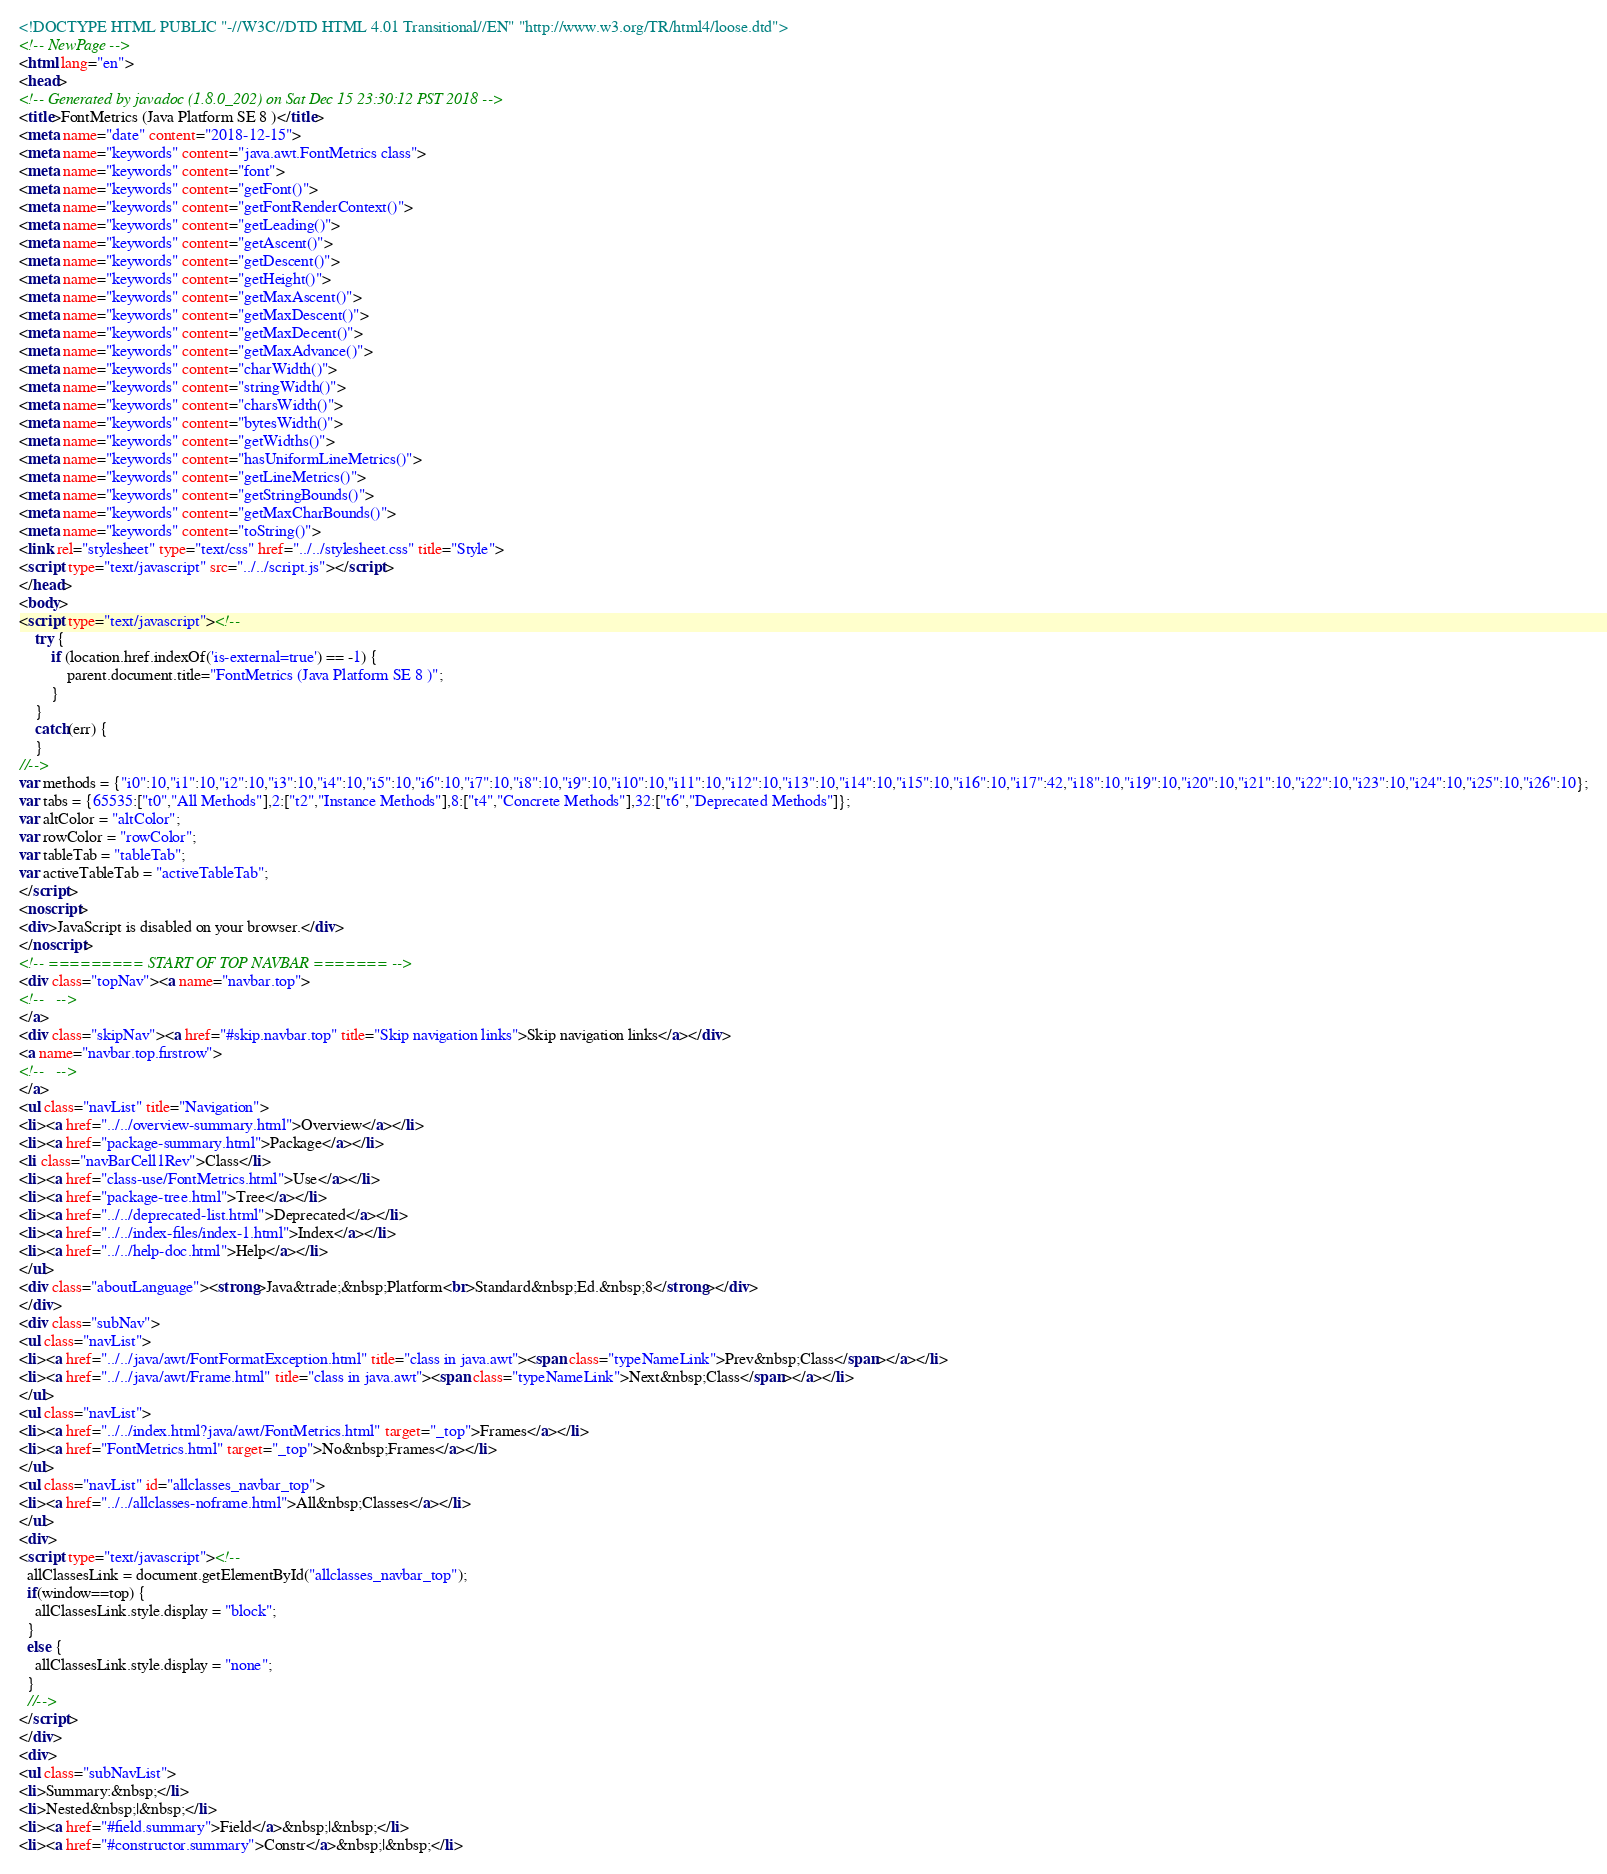<code> <loc_0><loc_0><loc_500><loc_500><_HTML_><!DOCTYPE HTML PUBLIC "-//W3C//DTD HTML 4.01 Transitional//EN" "http://www.w3.org/TR/html4/loose.dtd">
<!-- NewPage -->
<html lang="en">
<head>
<!-- Generated by javadoc (1.8.0_202) on Sat Dec 15 23:30:12 PST 2018 -->
<title>FontMetrics (Java Platform SE 8 )</title>
<meta name="date" content="2018-12-15">
<meta name="keywords" content="java.awt.FontMetrics class">
<meta name="keywords" content="font">
<meta name="keywords" content="getFont()">
<meta name="keywords" content="getFontRenderContext()">
<meta name="keywords" content="getLeading()">
<meta name="keywords" content="getAscent()">
<meta name="keywords" content="getDescent()">
<meta name="keywords" content="getHeight()">
<meta name="keywords" content="getMaxAscent()">
<meta name="keywords" content="getMaxDescent()">
<meta name="keywords" content="getMaxDecent()">
<meta name="keywords" content="getMaxAdvance()">
<meta name="keywords" content="charWidth()">
<meta name="keywords" content="stringWidth()">
<meta name="keywords" content="charsWidth()">
<meta name="keywords" content="bytesWidth()">
<meta name="keywords" content="getWidths()">
<meta name="keywords" content="hasUniformLineMetrics()">
<meta name="keywords" content="getLineMetrics()">
<meta name="keywords" content="getStringBounds()">
<meta name="keywords" content="getMaxCharBounds()">
<meta name="keywords" content="toString()">
<link rel="stylesheet" type="text/css" href="../../stylesheet.css" title="Style">
<script type="text/javascript" src="../../script.js"></script>
</head>
<body>
<script type="text/javascript"><!--
    try {
        if (location.href.indexOf('is-external=true') == -1) {
            parent.document.title="FontMetrics (Java Platform SE 8 )";
        }
    }
    catch(err) {
    }
//-->
var methods = {"i0":10,"i1":10,"i2":10,"i3":10,"i4":10,"i5":10,"i6":10,"i7":10,"i8":10,"i9":10,"i10":10,"i11":10,"i12":10,"i13":10,"i14":10,"i15":10,"i16":10,"i17":42,"i18":10,"i19":10,"i20":10,"i21":10,"i22":10,"i23":10,"i24":10,"i25":10,"i26":10};
var tabs = {65535:["t0","All Methods"],2:["t2","Instance Methods"],8:["t4","Concrete Methods"],32:["t6","Deprecated Methods"]};
var altColor = "altColor";
var rowColor = "rowColor";
var tableTab = "tableTab";
var activeTableTab = "activeTableTab";
</script>
<noscript>
<div>JavaScript is disabled on your browser.</div>
</noscript>
<!-- ========= START OF TOP NAVBAR ======= -->
<div class="topNav"><a name="navbar.top">
<!--   -->
</a>
<div class="skipNav"><a href="#skip.navbar.top" title="Skip navigation links">Skip navigation links</a></div>
<a name="navbar.top.firstrow">
<!--   -->
</a>
<ul class="navList" title="Navigation">
<li><a href="../../overview-summary.html">Overview</a></li>
<li><a href="package-summary.html">Package</a></li>
<li class="navBarCell1Rev">Class</li>
<li><a href="class-use/FontMetrics.html">Use</a></li>
<li><a href="package-tree.html">Tree</a></li>
<li><a href="../../deprecated-list.html">Deprecated</a></li>
<li><a href="../../index-files/index-1.html">Index</a></li>
<li><a href="../../help-doc.html">Help</a></li>
</ul>
<div class="aboutLanguage"><strong>Java&trade;&nbsp;Platform<br>Standard&nbsp;Ed.&nbsp;8</strong></div>
</div>
<div class="subNav">
<ul class="navList">
<li><a href="../../java/awt/FontFormatException.html" title="class in java.awt"><span class="typeNameLink">Prev&nbsp;Class</span></a></li>
<li><a href="../../java/awt/Frame.html" title="class in java.awt"><span class="typeNameLink">Next&nbsp;Class</span></a></li>
</ul>
<ul class="navList">
<li><a href="../../index.html?java/awt/FontMetrics.html" target="_top">Frames</a></li>
<li><a href="FontMetrics.html" target="_top">No&nbsp;Frames</a></li>
</ul>
<ul class="navList" id="allclasses_navbar_top">
<li><a href="../../allclasses-noframe.html">All&nbsp;Classes</a></li>
</ul>
<div>
<script type="text/javascript"><!--
  allClassesLink = document.getElementById("allclasses_navbar_top");
  if(window==top) {
    allClassesLink.style.display = "block";
  }
  else {
    allClassesLink.style.display = "none";
  }
  //-->
</script>
</div>
<div>
<ul class="subNavList">
<li>Summary:&nbsp;</li>
<li>Nested&nbsp;|&nbsp;</li>
<li><a href="#field.summary">Field</a>&nbsp;|&nbsp;</li>
<li><a href="#constructor.summary">Constr</a>&nbsp;|&nbsp;</li></code> 